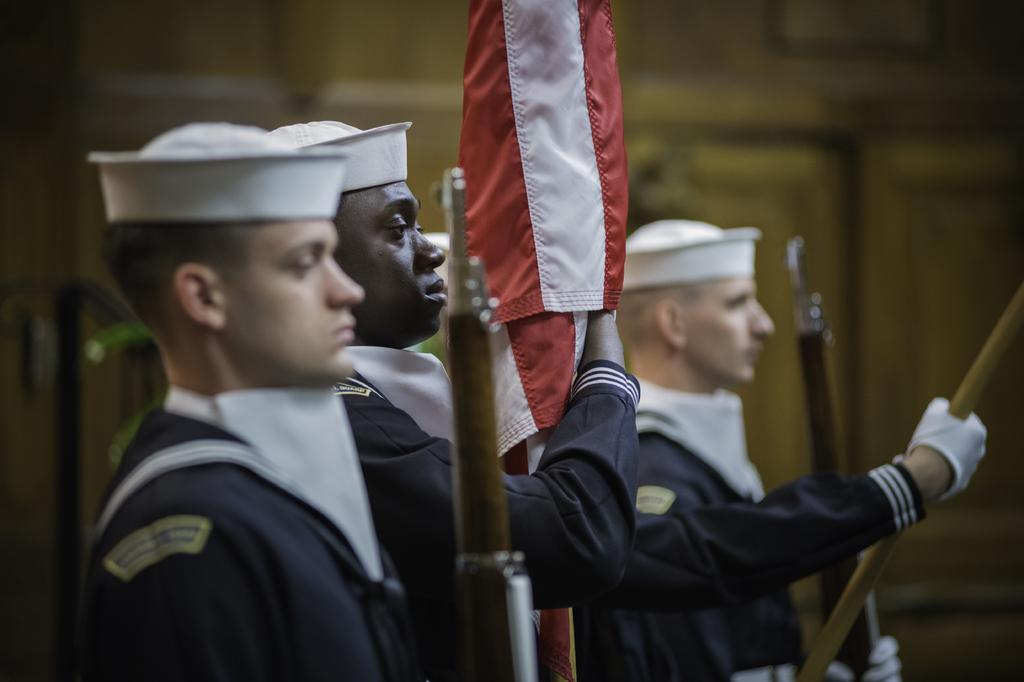What type of people are in the image? There are men in the image. What are the men wearing? The men are wearing uniforms and caps on their heads. What are the men holding in their hands? The men are holding flags in their hands. In which direction are the men facing? The men are facing towards the right side. How would you describe the background of the image? The background of the image is blurred. What scientific theory is being discussed by the men in the image? There is no indication in the image that the men are discussing any scientific theory. 